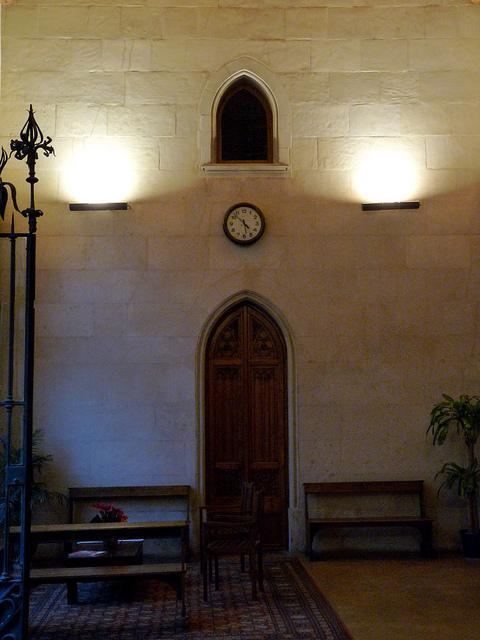How many lights are there?
Give a very brief answer. 2. How many benches are in the photo?
Give a very brief answer. 2. How many potted plants are there?
Give a very brief answer. 2. 